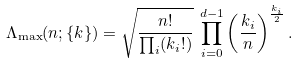<formula> <loc_0><loc_0><loc_500><loc_500>\Lambda _ { \max } ( n ; \{ k \} ) = \sqrt { \frac { n ! } { \prod _ { i } ( k _ { i } ! ) } } \, \prod _ { i = 0 } ^ { d - 1 } \left ( \frac { k _ { i } } { n } \right ) ^ { \frac { k _ { i } } { 2 } } .</formula> 